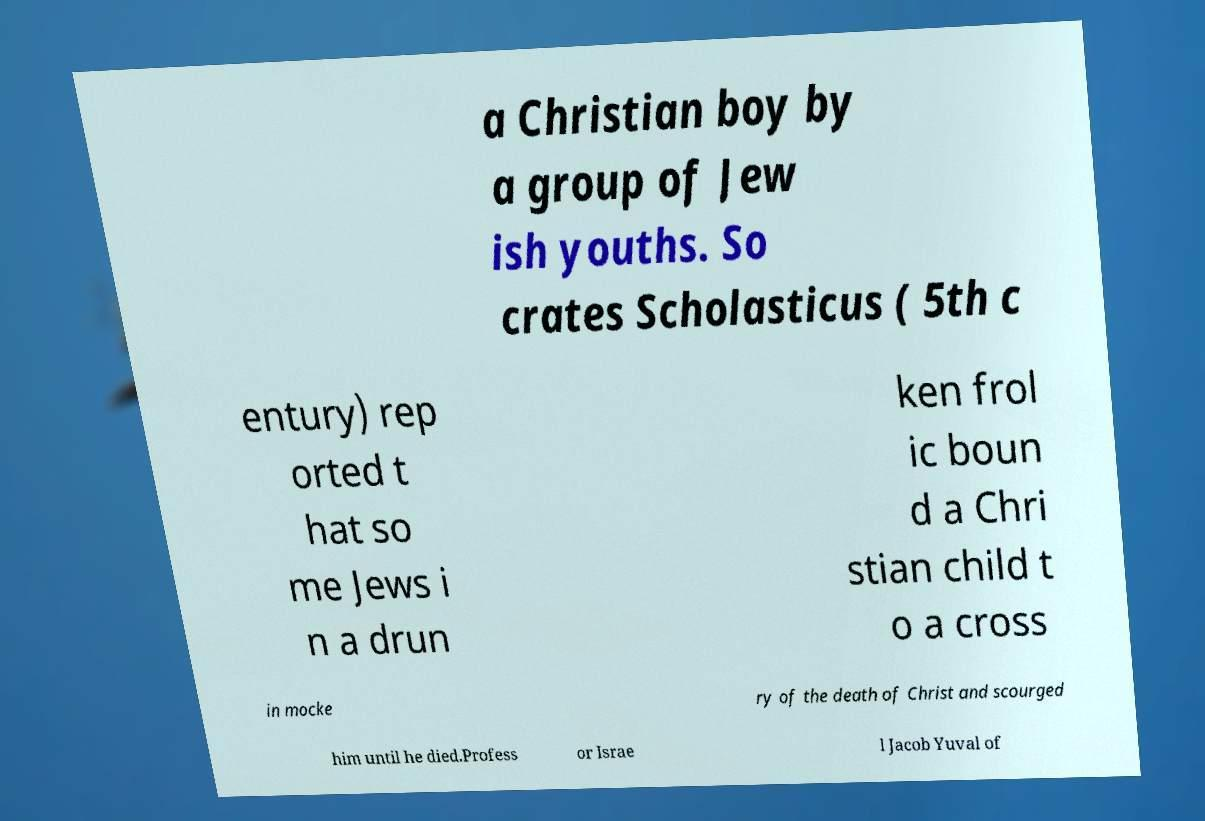Could you extract and type out the text from this image? a Christian boy by a group of Jew ish youths. So crates Scholasticus ( 5th c entury) rep orted t hat so me Jews i n a drun ken frol ic boun d a Chri stian child t o a cross in mocke ry of the death of Christ and scourged him until he died.Profess or Israe l Jacob Yuval of 